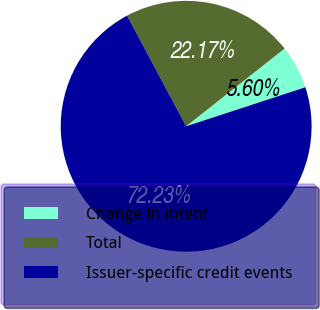<chart> <loc_0><loc_0><loc_500><loc_500><pie_chart><fcel>Change in intent<fcel>Total<fcel>Issuer-specific credit events<nl><fcel>5.6%<fcel>22.17%<fcel>72.23%<nl></chart> 